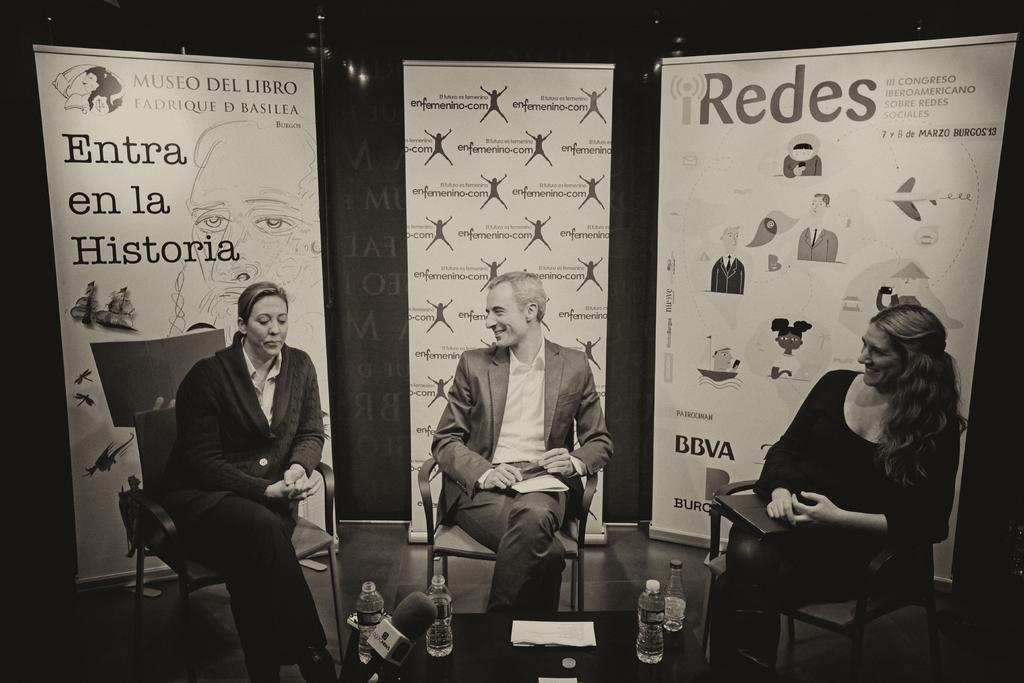How many people are in the image? There are three people in the image. What are the people doing in the image? The people are sitting on chairs. What is on the table in the image? There is a bottle on the table. What can be seen in the background of the image? There is a poster visible in the background. What type of floor can be seen in the image? There is no information about the floor in the image, as the focus is on the people, chairs, table, bottle, and poster. 